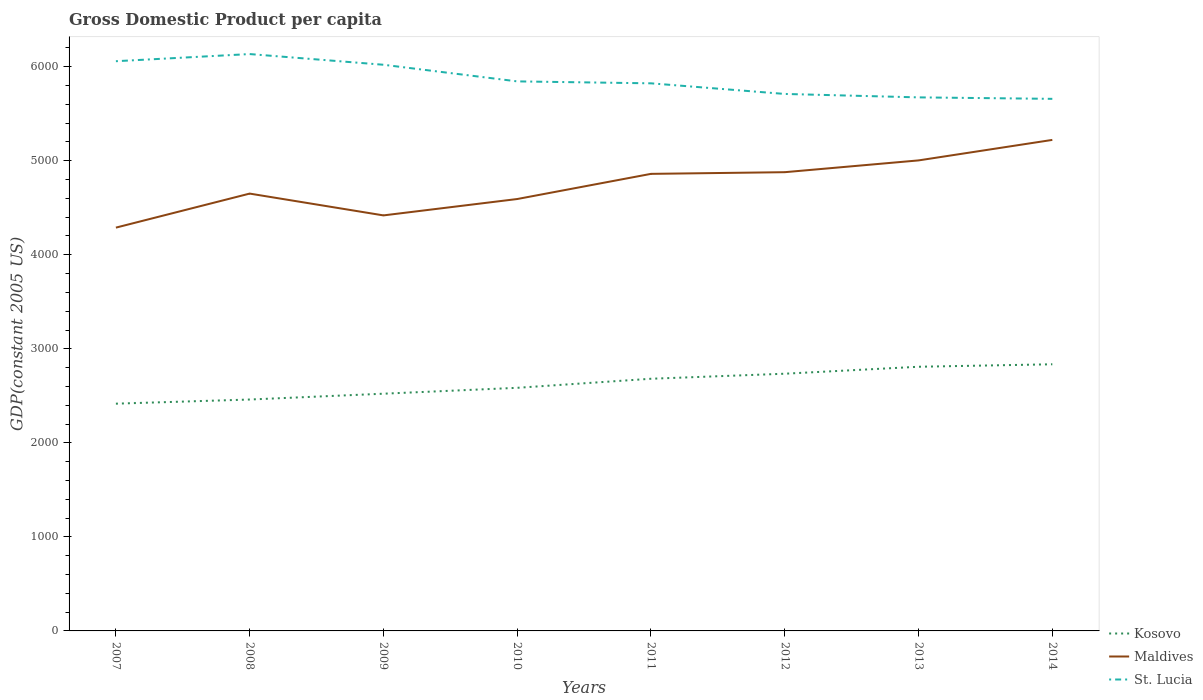How many different coloured lines are there?
Provide a succinct answer. 3. Does the line corresponding to Maldives intersect with the line corresponding to St. Lucia?
Offer a terse response. No. Across all years, what is the maximum GDP per capita in Maldives?
Ensure brevity in your answer.  4289.08. What is the total GDP per capita in St. Lucia in the graph?
Your answer should be very brief. 52.19. What is the difference between the highest and the second highest GDP per capita in Maldives?
Give a very brief answer. 932.86. Is the GDP per capita in Maldives strictly greater than the GDP per capita in St. Lucia over the years?
Offer a terse response. Yes. How many years are there in the graph?
Provide a succinct answer. 8. What is the difference between two consecutive major ticks on the Y-axis?
Offer a terse response. 1000. Are the values on the major ticks of Y-axis written in scientific E-notation?
Your answer should be compact. No. How many legend labels are there?
Provide a succinct answer. 3. What is the title of the graph?
Keep it short and to the point. Gross Domestic Product per capita. What is the label or title of the X-axis?
Make the answer very short. Years. What is the label or title of the Y-axis?
Give a very brief answer. GDP(constant 2005 US). What is the GDP(constant 2005 US) in Kosovo in 2007?
Make the answer very short. 2416.85. What is the GDP(constant 2005 US) in Maldives in 2007?
Your response must be concise. 4289.08. What is the GDP(constant 2005 US) in St. Lucia in 2007?
Offer a very short reply. 6058.86. What is the GDP(constant 2005 US) of Kosovo in 2008?
Your response must be concise. 2460.92. What is the GDP(constant 2005 US) of Maldives in 2008?
Keep it short and to the point. 4650.98. What is the GDP(constant 2005 US) in St. Lucia in 2008?
Provide a succinct answer. 6134.96. What is the GDP(constant 2005 US) of Kosovo in 2009?
Ensure brevity in your answer.  2522.81. What is the GDP(constant 2005 US) in Maldives in 2009?
Give a very brief answer. 4419.06. What is the GDP(constant 2005 US) in St. Lucia in 2009?
Make the answer very short. 6021.13. What is the GDP(constant 2005 US) in Kosovo in 2010?
Make the answer very short. 2585.46. What is the GDP(constant 2005 US) in Maldives in 2010?
Offer a very short reply. 4593.24. What is the GDP(constant 2005 US) in St. Lucia in 2010?
Your answer should be very brief. 5844.34. What is the GDP(constant 2005 US) of Kosovo in 2011?
Make the answer very short. 2681.82. What is the GDP(constant 2005 US) of Maldives in 2011?
Offer a terse response. 4860.83. What is the GDP(constant 2005 US) in St. Lucia in 2011?
Offer a terse response. 5823.61. What is the GDP(constant 2005 US) in Kosovo in 2012?
Your answer should be very brief. 2735.38. What is the GDP(constant 2005 US) in Maldives in 2012?
Offer a terse response. 4878.65. What is the GDP(constant 2005 US) in St. Lucia in 2012?
Offer a terse response. 5710.75. What is the GDP(constant 2005 US) in Kosovo in 2013?
Offer a very short reply. 2809.39. What is the GDP(constant 2005 US) in Maldives in 2013?
Your answer should be compact. 5003.96. What is the GDP(constant 2005 US) in St. Lucia in 2013?
Your response must be concise. 5674.27. What is the GDP(constant 2005 US) in Kosovo in 2014?
Your answer should be compact. 2835.78. What is the GDP(constant 2005 US) of Maldives in 2014?
Ensure brevity in your answer.  5221.95. What is the GDP(constant 2005 US) in St. Lucia in 2014?
Keep it short and to the point. 5658.56. Across all years, what is the maximum GDP(constant 2005 US) of Kosovo?
Provide a succinct answer. 2835.78. Across all years, what is the maximum GDP(constant 2005 US) of Maldives?
Your response must be concise. 5221.95. Across all years, what is the maximum GDP(constant 2005 US) of St. Lucia?
Provide a short and direct response. 6134.96. Across all years, what is the minimum GDP(constant 2005 US) of Kosovo?
Provide a short and direct response. 2416.85. Across all years, what is the minimum GDP(constant 2005 US) of Maldives?
Offer a very short reply. 4289.08. Across all years, what is the minimum GDP(constant 2005 US) in St. Lucia?
Offer a very short reply. 5658.56. What is the total GDP(constant 2005 US) in Kosovo in the graph?
Ensure brevity in your answer.  2.10e+04. What is the total GDP(constant 2005 US) in Maldives in the graph?
Make the answer very short. 3.79e+04. What is the total GDP(constant 2005 US) in St. Lucia in the graph?
Provide a succinct answer. 4.69e+04. What is the difference between the GDP(constant 2005 US) of Kosovo in 2007 and that in 2008?
Provide a succinct answer. -44.08. What is the difference between the GDP(constant 2005 US) of Maldives in 2007 and that in 2008?
Ensure brevity in your answer.  -361.89. What is the difference between the GDP(constant 2005 US) in St. Lucia in 2007 and that in 2008?
Keep it short and to the point. -76.11. What is the difference between the GDP(constant 2005 US) in Kosovo in 2007 and that in 2009?
Provide a short and direct response. -105.97. What is the difference between the GDP(constant 2005 US) of Maldives in 2007 and that in 2009?
Offer a very short reply. -129.97. What is the difference between the GDP(constant 2005 US) of St. Lucia in 2007 and that in 2009?
Your answer should be compact. 37.72. What is the difference between the GDP(constant 2005 US) of Kosovo in 2007 and that in 2010?
Offer a terse response. -168.61. What is the difference between the GDP(constant 2005 US) of Maldives in 2007 and that in 2010?
Make the answer very short. -304.15. What is the difference between the GDP(constant 2005 US) in St. Lucia in 2007 and that in 2010?
Your response must be concise. 214.51. What is the difference between the GDP(constant 2005 US) in Kosovo in 2007 and that in 2011?
Make the answer very short. -264.97. What is the difference between the GDP(constant 2005 US) of Maldives in 2007 and that in 2011?
Your response must be concise. -571.75. What is the difference between the GDP(constant 2005 US) of St. Lucia in 2007 and that in 2011?
Offer a very short reply. 235.25. What is the difference between the GDP(constant 2005 US) in Kosovo in 2007 and that in 2012?
Provide a short and direct response. -318.54. What is the difference between the GDP(constant 2005 US) of Maldives in 2007 and that in 2012?
Provide a succinct answer. -589.57. What is the difference between the GDP(constant 2005 US) in St. Lucia in 2007 and that in 2012?
Make the answer very short. 348.11. What is the difference between the GDP(constant 2005 US) in Kosovo in 2007 and that in 2013?
Provide a succinct answer. -392.55. What is the difference between the GDP(constant 2005 US) of Maldives in 2007 and that in 2013?
Provide a short and direct response. -714.88. What is the difference between the GDP(constant 2005 US) in St. Lucia in 2007 and that in 2013?
Ensure brevity in your answer.  384.58. What is the difference between the GDP(constant 2005 US) of Kosovo in 2007 and that in 2014?
Provide a succinct answer. -418.93. What is the difference between the GDP(constant 2005 US) of Maldives in 2007 and that in 2014?
Offer a very short reply. -932.87. What is the difference between the GDP(constant 2005 US) in St. Lucia in 2007 and that in 2014?
Give a very brief answer. 400.29. What is the difference between the GDP(constant 2005 US) of Kosovo in 2008 and that in 2009?
Your response must be concise. -61.89. What is the difference between the GDP(constant 2005 US) in Maldives in 2008 and that in 2009?
Offer a very short reply. 231.92. What is the difference between the GDP(constant 2005 US) of St. Lucia in 2008 and that in 2009?
Provide a succinct answer. 113.83. What is the difference between the GDP(constant 2005 US) in Kosovo in 2008 and that in 2010?
Your answer should be very brief. -124.53. What is the difference between the GDP(constant 2005 US) in Maldives in 2008 and that in 2010?
Provide a short and direct response. 57.74. What is the difference between the GDP(constant 2005 US) of St. Lucia in 2008 and that in 2010?
Offer a terse response. 290.62. What is the difference between the GDP(constant 2005 US) of Kosovo in 2008 and that in 2011?
Make the answer very short. -220.9. What is the difference between the GDP(constant 2005 US) in Maldives in 2008 and that in 2011?
Ensure brevity in your answer.  -209.85. What is the difference between the GDP(constant 2005 US) of St. Lucia in 2008 and that in 2011?
Offer a terse response. 311.35. What is the difference between the GDP(constant 2005 US) in Kosovo in 2008 and that in 2012?
Ensure brevity in your answer.  -274.46. What is the difference between the GDP(constant 2005 US) in Maldives in 2008 and that in 2012?
Provide a short and direct response. -227.68. What is the difference between the GDP(constant 2005 US) in St. Lucia in 2008 and that in 2012?
Offer a very short reply. 424.21. What is the difference between the GDP(constant 2005 US) of Kosovo in 2008 and that in 2013?
Give a very brief answer. -348.47. What is the difference between the GDP(constant 2005 US) of Maldives in 2008 and that in 2013?
Give a very brief answer. -352.99. What is the difference between the GDP(constant 2005 US) of St. Lucia in 2008 and that in 2013?
Provide a succinct answer. 460.69. What is the difference between the GDP(constant 2005 US) in Kosovo in 2008 and that in 2014?
Your response must be concise. -374.86. What is the difference between the GDP(constant 2005 US) in Maldives in 2008 and that in 2014?
Offer a terse response. -570.97. What is the difference between the GDP(constant 2005 US) of St. Lucia in 2008 and that in 2014?
Your answer should be very brief. 476.4. What is the difference between the GDP(constant 2005 US) of Kosovo in 2009 and that in 2010?
Provide a succinct answer. -62.64. What is the difference between the GDP(constant 2005 US) in Maldives in 2009 and that in 2010?
Offer a very short reply. -174.18. What is the difference between the GDP(constant 2005 US) in St. Lucia in 2009 and that in 2010?
Your answer should be compact. 176.79. What is the difference between the GDP(constant 2005 US) in Kosovo in 2009 and that in 2011?
Your response must be concise. -159.01. What is the difference between the GDP(constant 2005 US) of Maldives in 2009 and that in 2011?
Your answer should be very brief. -441.77. What is the difference between the GDP(constant 2005 US) of St. Lucia in 2009 and that in 2011?
Provide a short and direct response. 197.53. What is the difference between the GDP(constant 2005 US) in Kosovo in 2009 and that in 2012?
Your answer should be very brief. -212.57. What is the difference between the GDP(constant 2005 US) of Maldives in 2009 and that in 2012?
Provide a succinct answer. -459.6. What is the difference between the GDP(constant 2005 US) of St. Lucia in 2009 and that in 2012?
Provide a short and direct response. 310.39. What is the difference between the GDP(constant 2005 US) of Kosovo in 2009 and that in 2013?
Your response must be concise. -286.58. What is the difference between the GDP(constant 2005 US) of Maldives in 2009 and that in 2013?
Offer a very short reply. -584.91. What is the difference between the GDP(constant 2005 US) of St. Lucia in 2009 and that in 2013?
Your answer should be very brief. 346.86. What is the difference between the GDP(constant 2005 US) in Kosovo in 2009 and that in 2014?
Make the answer very short. -312.96. What is the difference between the GDP(constant 2005 US) of Maldives in 2009 and that in 2014?
Your response must be concise. -802.89. What is the difference between the GDP(constant 2005 US) in St. Lucia in 2009 and that in 2014?
Ensure brevity in your answer.  362.57. What is the difference between the GDP(constant 2005 US) in Kosovo in 2010 and that in 2011?
Provide a short and direct response. -96.36. What is the difference between the GDP(constant 2005 US) in Maldives in 2010 and that in 2011?
Provide a short and direct response. -267.59. What is the difference between the GDP(constant 2005 US) of St. Lucia in 2010 and that in 2011?
Your response must be concise. 20.73. What is the difference between the GDP(constant 2005 US) of Kosovo in 2010 and that in 2012?
Provide a short and direct response. -149.93. What is the difference between the GDP(constant 2005 US) in Maldives in 2010 and that in 2012?
Offer a very short reply. -285.42. What is the difference between the GDP(constant 2005 US) in St. Lucia in 2010 and that in 2012?
Provide a succinct answer. 133.6. What is the difference between the GDP(constant 2005 US) in Kosovo in 2010 and that in 2013?
Ensure brevity in your answer.  -223.94. What is the difference between the GDP(constant 2005 US) of Maldives in 2010 and that in 2013?
Offer a very short reply. -410.73. What is the difference between the GDP(constant 2005 US) in St. Lucia in 2010 and that in 2013?
Offer a terse response. 170.07. What is the difference between the GDP(constant 2005 US) of Kosovo in 2010 and that in 2014?
Your answer should be compact. -250.32. What is the difference between the GDP(constant 2005 US) of Maldives in 2010 and that in 2014?
Your answer should be compact. -628.71. What is the difference between the GDP(constant 2005 US) in St. Lucia in 2010 and that in 2014?
Your answer should be very brief. 185.78. What is the difference between the GDP(constant 2005 US) in Kosovo in 2011 and that in 2012?
Keep it short and to the point. -53.56. What is the difference between the GDP(constant 2005 US) in Maldives in 2011 and that in 2012?
Your answer should be compact. -17.82. What is the difference between the GDP(constant 2005 US) in St. Lucia in 2011 and that in 2012?
Provide a short and direct response. 112.86. What is the difference between the GDP(constant 2005 US) in Kosovo in 2011 and that in 2013?
Provide a succinct answer. -127.57. What is the difference between the GDP(constant 2005 US) of Maldives in 2011 and that in 2013?
Your answer should be compact. -143.13. What is the difference between the GDP(constant 2005 US) of St. Lucia in 2011 and that in 2013?
Your response must be concise. 149.33. What is the difference between the GDP(constant 2005 US) of Kosovo in 2011 and that in 2014?
Provide a short and direct response. -153.96. What is the difference between the GDP(constant 2005 US) of Maldives in 2011 and that in 2014?
Give a very brief answer. -361.12. What is the difference between the GDP(constant 2005 US) in St. Lucia in 2011 and that in 2014?
Provide a succinct answer. 165.05. What is the difference between the GDP(constant 2005 US) of Kosovo in 2012 and that in 2013?
Keep it short and to the point. -74.01. What is the difference between the GDP(constant 2005 US) in Maldives in 2012 and that in 2013?
Your response must be concise. -125.31. What is the difference between the GDP(constant 2005 US) of St. Lucia in 2012 and that in 2013?
Your answer should be very brief. 36.47. What is the difference between the GDP(constant 2005 US) in Kosovo in 2012 and that in 2014?
Offer a very short reply. -100.39. What is the difference between the GDP(constant 2005 US) in Maldives in 2012 and that in 2014?
Your answer should be compact. -343.3. What is the difference between the GDP(constant 2005 US) of St. Lucia in 2012 and that in 2014?
Make the answer very short. 52.19. What is the difference between the GDP(constant 2005 US) in Kosovo in 2013 and that in 2014?
Your answer should be very brief. -26.38. What is the difference between the GDP(constant 2005 US) in Maldives in 2013 and that in 2014?
Ensure brevity in your answer.  -217.99. What is the difference between the GDP(constant 2005 US) in St. Lucia in 2013 and that in 2014?
Keep it short and to the point. 15.71. What is the difference between the GDP(constant 2005 US) in Kosovo in 2007 and the GDP(constant 2005 US) in Maldives in 2008?
Make the answer very short. -2234.13. What is the difference between the GDP(constant 2005 US) in Kosovo in 2007 and the GDP(constant 2005 US) in St. Lucia in 2008?
Your answer should be very brief. -3718.11. What is the difference between the GDP(constant 2005 US) in Maldives in 2007 and the GDP(constant 2005 US) in St. Lucia in 2008?
Your answer should be compact. -1845.88. What is the difference between the GDP(constant 2005 US) in Kosovo in 2007 and the GDP(constant 2005 US) in Maldives in 2009?
Make the answer very short. -2002.21. What is the difference between the GDP(constant 2005 US) of Kosovo in 2007 and the GDP(constant 2005 US) of St. Lucia in 2009?
Offer a terse response. -3604.29. What is the difference between the GDP(constant 2005 US) in Maldives in 2007 and the GDP(constant 2005 US) in St. Lucia in 2009?
Ensure brevity in your answer.  -1732.05. What is the difference between the GDP(constant 2005 US) in Kosovo in 2007 and the GDP(constant 2005 US) in Maldives in 2010?
Provide a succinct answer. -2176.39. What is the difference between the GDP(constant 2005 US) of Kosovo in 2007 and the GDP(constant 2005 US) of St. Lucia in 2010?
Keep it short and to the point. -3427.49. What is the difference between the GDP(constant 2005 US) in Maldives in 2007 and the GDP(constant 2005 US) in St. Lucia in 2010?
Provide a short and direct response. -1555.26. What is the difference between the GDP(constant 2005 US) of Kosovo in 2007 and the GDP(constant 2005 US) of Maldives in 2011?
Provide a short and direct response. -2443.98. What is the difference between the GDP(constant 2005 US) in Kosovo in 2007 and the GDP(constant 2005 US) in St. Lucia in 2011?
Keep it short and to the point. -3406.76. What is the difference between the GDP(constant 2005 US) of Maldives in 2007 and the GDP(constant 2005 US) of St. Lucia in 2011?
Keep it short and to the point. -1534.53. What is the difference between the GDP(constant 2005 US) of Kosovo in 2007 and the GDP(constant 2005 US) of Maldives in 2012?
Your answer should be compact. -2461.81. What is the difference between the GDP(constant 2005 US) of Kosovo in 2007 and the GDP(constant 2005 US) of St. Lucia in 2012?
Your answer should be very brief. -3293.9. What is the difference between the GDP(constant 2005 US) of Maldives in 2007 and the GDP(constant 2005 US) of St. Lucia in 2012?
Offer a very short reply. -1421.66. What is the difference between the GDP(constant 2005 US) in Kosovo in 2007 and the GDP(constant 2005 US) in Maldives in 2013?
Your answer should be compact. -2587.11. What is the difference between the GDP(constant 2005 US) of Kosovo in 2007 and the GDP(constant 2005 US) of St. Lucia in 2013?
Keep it short and to the point. -3257.43. What is the difference between the GDP(constant 2005 US) in Maldives in 2007 and the GDP(constant 2005 US) in St. Lucia in 2013?
Make the answer very short. -1385.19. What is the difference between the GDP(constant 2005 US) of Kosovo in 2007 and the GDP(constant 2005 US) of Maldives in 2014?
Offer a terse response. -2805.1. What is the difference between the GDP(constant 2005 US) in Kosovo in 2007 and the GDP(constant 2005 US) in St. Lucia in 2014?
Your answer should be very brief. -3241.71. What is the difference between the GDP(constant 2005 US) in Maldives in 2007 and the GDP(constant 2005 US) in St. Lucia in 2014?
Provide a short and direct response. -1369.48. What is the difference between the GDP(constant 2005 US) in Kosovo in 2008 and the GDP(constant 2005 US) in Maldives in 2009?
Give a very brief answer. -1958.13. What is the difference between the GDP(constant 2005 US) in Kosovo in 2008 and the GDP(constant 2005 US) in St. Lucia in 2009?
Your answer should be very brief. -3560.21. What is the difference between the GDP(constant 2005 US) in Maldives in 2008 and the GDP(constant 2005 US) in St. Lucia in 2009?
Your answer should be compact. -1370.16. What is the difference between the GDP(constant 2005 US) of Kosovo in 2008 and the GDP(constant 2005 US) of Maldives in 2010?
Provide a short and direct response. -2132.31. What is the difference between the GDP(constant 2005 US) in Kosovo in 2008 and the GDP(constant 2005 US) in St. Lucia in 2010?
Keep it short and to the point. -3383.42. What is the difference between the GDP(constant 2005 US) of Maldives in 2008 and the GDP(constant 2005 US) of St. Lucia in 2010?
Offer a very short reply. -1193.37. What is the difference between the GDP(constant 2005 US) of Kosovo in 2008 and the GDP(constant 2005 US) of Maldives in 2011?
Offer a very short reply. -2399.91. What is the difference between the GDP(constant 2005 US) of Kosovo in 2008 and the GDP(constant 2005 US) of St. Lucia in 2011?
Ensure brevity in your answer.  -3362.69. What is the difference between the GDP(constant 2005 US) in Maldives in 2008 and the GDP(constant 2005 US) in St. Lucia in 2011?
Provide a short and direct response. -1172.63. What is the difference between the GDP(constant 2005 US) of Kosovo in 2008 and the GDP(constant 2005 US) of Maldives in 2012?
Ensure brevity in your answer.  -2417.73. What is the difference between the GDP(constant 2005 US) in Kosovo in 2008 and the GDP(constant 2005 US) in St. Lucia in 2012?
Your answer should be compact. -3249.82. What is the difference between the GDP(constant 2005 US) of Maldives in 2008 and the GDP(constant 2005 US) of St. Lucia in 2012?
Your response must be concise. -1059.77. What is the difference between the GDP(constant 2005 US) of Kosovo in 2008 and the GDP(constant 2005 US) of Maldives in 2013?
Provide a short and direct response. -2543.04. What is the difference between the GDP(constant 2005 US) of Kosovo in 2008 and the GDP(constant 2005 US) of St. Lucia in 2013?
Ensure brevity in your answer.  -3213.35. What is the difference between the GDP(constant 2005 US) of Maldives in 2008 and the GDP(constant 2005 US) of St. Lucia in 2013?
Provide a succinct answer. -1023.3. What is the difference between the GDP(constant 2005 US) in Kosovo in 2008 and the GDP(constant 2005 US) in Maldives in 2014?
Your answer should be very brief. -2761.03. What is the difference between the GDP(constant 2005 US) of Kosovo in 2008 and the GDP(constant 2005 US) of St. Lucia in 2014?
Your answer should be very brief. -3197.64. What is the difference between the GDP(constant 2005 US) in Maldives in 2008 and the GDP(constant 2005 US) in St. Lucia in 2014?
Your response must be concise. -1007.59. What is the difference between the GDP(constant 2005 US) of Kosovo in 2009 and the GDP(constant 2005 US) of Maldives in 2010?
Make the answer very short. -2070.42. What is the difference between the GDP(constant 2005 US) of Kosovo in 2009 and the GDP(constant 2005 US) of St. Lucia in 2010?
Make the answer very short. -3321.53. What is the difference between the GDP(constant 2005 US) in Maldives in 2009 and the GDP(constant 2005 US) in St. Lucia in 2010?
Ensure brevity in your answer.  -1425.29. What is the difference between the GDP(constant 2005 US) of Kosovo in 2009 and the GDP(constant 2005 US) of Maldives in 2011?
Offer a very short reply. -2338.02. What is the difference between the GDP(constant 2005 US) in Kosovo in 2009 and the GDP(constant 2005 US) in St. Lucia in 2011?
Offer a very short reply. -3300.79. What is the difference between the GDP(constant 2005 US) in Maldives in 2009 and the GDP(constant 2005 US) in St. Lucia in 2011?
Provide a short and direct response. -1404.55. What is the difference between the GDP(constant 2005 US) in Kosovo in 2009 and the GDP(constant 2005 US) in Maldives in 2012?
Make the answer very short. -2355.84. What is the difference between the GDP(constant 2005 US) in Kosovo in 2009 and the GDP(constant 2005 US) in St. Lucia in 2012?
Give a very brief answer. -3187.93. What is the difference between the GDP(constant 2005 US) of Maldives in 2009 and the GDP(constant 2005 US) of St. Lucia in 2012?
Your answer should be compact. -1291.69. What is the difference between the GDP(constant 2005 US) of Kosovo in 2009 and the GDP(constant 2005 US) of Maldives in 2013?
Make the answer very short. -2481.15. What is the difference between the GDP(constant 2005 US) of Kosovo in 2009 and the GDP(constant 2005 US) of St. Lucia in 2013?
Your response must be concise. -3151.46. What is the difference between the GDP(constant 2005 US) in Maldives in 2009 and the GDP(constant 2005 US) in St. Lucia in 2013?
Offer a terse response. -1255.22. What is the difference between the GDP(constant 2005 US) in Kosovo in 2009 and the GDP(constant 2005 US) in Maldives in 2014?
Offer a terse response. -2699.13. What is the difference between the GDP(constant 2005 US) of Kosovo in 2009 and the GDP(constant 2005 US) of St. Lucia in 2014?
Your response must be concise. -3135.75. What is the difference between the GDP(constant 2005 US) of Maldives in 2009 and the GDP(constant 2005 US) of St. Lucia in 2014?
Keep it short and to the point. -1239.51. What is the difference between the GDP(constant 2005 US) of Kosovo in 2010 and the GDP(constant 2005 US) of Maldives in 2011?
Your response must be concise. -2275.37. What is the difference between the GDP(constant 2005 US) in Kosovo in 2010 and the GDP(constant 2005 US) in St. Lucia in 2011?
Provide a short and direct response. -3238.15. What is the difference between the GDP(constant 2005 US) in Maldives in 2010 and the GDP(constant 2005 US) in St. Lucia in 2011?
Ensure brevity in your answer.  -1230.37. What is the difference between the GDP(constant 2005 US) in Kosovo in 2010 and the GDP(constant 2005 US) in Maldives in 2012?
Provide a succinct answer. -2293.2. What is the difference between the GDP(constant 2005 US) of Kosovo in 2010 and the GDP(constant 2005 US) of St. Lucia in 2012?
Offer a very short reply. -3125.29. What is the difference between the GDP(constant 2005 US) of Maldives in 2010 and the GDP(constant 2005 US) of St. Lucia in 2012?
Give a very brief answer. -1117.51. What is the difference between the GDP(constant 2005 US) in Kosovo in 2010 and the GDP(constant 2005 US) in Maldives in 2013?
Ensure brevity in your answer.  -2418.5. What is the difference between the GDP(constant 2005 US) of Kosovo in 2010 and the GDP(constant 2005 US) of St. Lucia in 2013?
Make the answer very short. -3088.82. What is the difference between the GDP(constant 2005 US) in Maldives in 2010 and the GDP(constant 2005 US) in St. Lucia in 2013?
Ensure brevity in your answer.  -1081.04. What is the difference between the GDP(constant 2005 US) of Kosovo in 2010 and the GDP(constant 2005 US) of Maldives in 2014?
Offer a terse response. -2636.49. What is the difference between the GDP(constant 2005 US) in Kosovo in 2010 and the GDP(constant 2005 US) in St. Lucia in 2014?
Make the answer very short. -3073.1. What is the difference between the GDP(constant 2005 US) of Maldives in 2010 and the GDP(constant 2005 US) of St. Lucia in 2014?
Make the answer very short. -1065.33. What is the difference between the GDP(constant 2005 US) of Kosovo in 2011 and the GDP(constant 2005 US) of Maldives in 2012?
Provide a succinct answer. -2196.83. What is the difference between the GDP(constant 2005 US) in Kosovo in 2011 and the GDP(constant 2005 US) in St. Lucia in 2012?
Make the answer very short. -3028.93. What is the difference between the GDP(constant 2005 US) of Maldives in 2011 and the GDP(constant 2005 US) of St. Lucia in 2012?
Provide a short and direct response. -849.92. What is the difference between the GDP(constant 2005 US) of Kosovo in 2011 and the GDP(constant 2005 US) of Maldives in 2013?
Provide a short and direct response. -2322.14. What is the difference between the GDP(constant 2005 US) in Kosovo in 2011 and the GDP(constant 2005 US) in St. Lucia in 2013?
Make the answer very short. -2992.45. What is the difference between the GDP(constant 2005 US) in Maldives in 2011 and the GDP(constant 2005 US) in St. Lucia in 2013?
Make the answer very short. -813.44. What is the difference between the GDP(constant 2005 US) of Kosovo in 2011 and the GDP(constant 2005 US) of Maldives in 2014?
Keep it short and to the point. -2540.13. What is the difference between the GDP(constant 2005 US) in Kosovo in 2011 and the GDP(constant 2005 US) in St. Lucia in 2014?
Your answer should be compact. -2976.74. What is the difference between the GDP(constant 2005 US) of Maldives in 2011 and the GDP(constant 2005 US) of St. Lucia in 2014?
Give a very brief answer. -797.73. What is the difference between the GDP(constant 2005 US) of Kosovo in 2012 and the GDP(constant 2005 US) of Maldives in 2013?
Keep it short and to the point. -2268.58. What is the difference between the GDP(constant 2005 US) in Kosovo in 2012 and the GDP(constant 2005 US) in St. Lucia in 2013?
Offer a very short reply. -2938.89. What is the difference between the GDP(constant 2005 US) of Maldives in 2012 and the GDP(constant 2005 US) of St. Lucia in 2013?
Offer a terse response. -795.62. What is the difference between the GDP(constant 2005 US) of Kosovo in 2012 and the GDP(constant 2005 US) of Maldives in 2014?
Your response must be concise. -2486.56. What is the difference between the GDP(constant 2005 US) in Kosovo in 2012 and the GDP(constant 2005 US) in St. Lucia in 2014?
Give a very brief answer. -2923.18. What is the difference between the GDP(constant 2005 US) in Maldives in 2012 and the GDP(constant 2005 US) in St. Lucia in 2014?
Ensure brevity in your answer.  -779.91. What is the difference between the GDP(constant 2005 US) in Kosovo in 2013 and the GDP(constant 2005 US) in Maldives in 2014?
Offer a terse response. -2412.56. What is the difference between the GDP(constant 2005 US) of Kosovo in 2013 and the GDP(constant 2005 US) of St. Lucia in 2014?
Provide a short and direct response. -2849.17. What is the difference between the GDP(constant 2005 US) in Maldives in 2013 and the GDP(constant 2005 US) in St. Lucia in 2014?
Your response must be concise. -654.6. What is the average GDP(constant 2005 US) in Kosovo per year?
Offer a very short reply. 2631.05. What is the average GDP(constant 2005 US) in Maldives per year?
Provide a short and direct response. 4739.72. What is the average GDP(constant 2005 US) in St. Lucia per year?
Make the answer very short. 5865.81. In the year 2007, what is the difference between the GDP(constant 2005 US) in Kosovo and GDP(constant 2005 US) in Maldives?
Offer a terse response. -1872.24. In the year 2007, what is the difference between the GDP(constant 2005 US) of Kosovo and GDP(constant 2005 US) of St. Lucia?
Offer a terse response. -3642.01. In the year 2007, what is the difference between the GDP(constant 2005 US) of Maldives and GDP(constant 2005 US) of St. Lucia?
Keep it short and to the point. -1769.77. In the year 2008, what is the difference between the GDP(constant 2005 US) of Kosovo and GDP(constant 2005 US) of Maldives?
Ensure brevity in your answer.  -2190.05. In the year 2008, what is the difference between the GDP(constant 2005 US) of Kosovo and GDP(constant 2005 US) of St. Lucia?
Your response must be concise. -3674.04. In the year 2008, what is the difference between the GDP(constant 2005 US) in Maldives and GDP(constant 2005 US) in St. Lucia?
Ensure brevity in your answer.  -1483.98. In the year 2009, what is the difference between the GDP(constant 2005 US) in Kosovo and GDP(constant 2005 US) in Maldives?
Make the answer very short. -1896.24. In the year 2009, what is the difference between the GDP(constant 2005 US) of Kosovo and GDP(constant 2005 US) of St. Lucia?
Provide a succinct answer. -3498.32. In the year 2009, what is the difference between the GDP(constant 2005 US) in Maldives and GDP(constant 2005 US) in St. Lucia?
Give a very brief answer. -1602.08. In the year 2010, what is the difference between the GDP(constant 2005 US) in Kosovo and GDP(constant 2005 US) in Maldives?
Provide a succinct answer. -2007.78. In the year 2010, what is the difference between the GDP(constant 2005 US) in Kosovo and GDP(constant 2005 US) in St. Lucia?
Give a very brief answer. -3258.88. In the year 2010, what is the difference between the GDP(constant 2005 US) in Maldives and GDP(constant 2005 US) in St. Lucia?
Offer a very short reply. -1251.11. In the year 2011, what is the difference between the GDP(constant 2005 US) of Kosovo and GDP(constant 2005 US) of Maldives?
Offer a terse response. -2179.01. In the year 2011, what is the difference between the GDP(constant 2005 US) of Kosovo and GDP(constant 2005 US) of St. Lucia?
Provide a succinct answer. -3141.79. In the year 2011, what is the difference between the GDP(constant 2005 US) in Maldives and GDP(constant 2005 US) in St. Lucia?
Give a very brief answer. -962.78. In the year 2012, what is the difference between the GDP(constant 2005 US) of Kosovo and GDP(constant 2005 US) of Maldives?
Your answer should be very brief. -2143.27. In the year 2012, what is the difference between the GDP(constant 2005 US) of Kosovo and GDP(constant 2005 US) of St. Lucia?
Make the answer very short. -2975.36. In the year 2012, what is the difference between the GDP(constant 2005 US) in Maldives and GDP(constant 2005 US) in St. Lucia?
Keep it short and to the point. -832.09. In the year 2013, what is the difference between the GDP(constant 2005 US) of Kosovo and GDP(constant 2005 US) of Maldives?
Make the answer very short. -2194.57. In the year 2013, what is the difference between the GDP(constant 2005 US) of Kosovo and GDP(constant 2005 US) of St. Lucia?
Offer a very short reply. -2864.88. In the year 2013, what is the difference between the GDP(constant 2005 US) in Maldives and GDP(constant 2005 US) in St. Lucia?
Your response must be concise. -670.31. In the year 2014, what is the difference between the GDP(constant 2005 US) of Kosovo and GDP(constant 2005 US) of Maldives?
Your answer should be compact. -2386.17. In the year 2014, what is the difference between the GDP(constant 2005 US) of Kosovo and GDP(constant 2005 US) of St. Lucia?
Offer a terse response. -2822.78. In the year 2014, what is the difference between the GDP(constant 2005 US) in Maldives and GDP(constant 2005 US) in St. Lucia?
Your answer should be very brief. -436.61. What is the ratio of the GDP(constant 2005 US) in Kosovo in 2007 to that in 2008?
Offer a terse response. 0.98. What is the ratio of the GDP(constant 2005 US) in Maldives in 2007 to that in 2008?
Give a very brief answer. 0.92. What is the ratio of the GDP(constant 2005 US) in St. Lucia in 2007 to that in 2008?
Your answer should be very brief. 0.99. What is the ratio of the GDP(constant 2005 US) in Kosovo in 2007 to that in 2009?
Your answer should be very brief. 0.96. What is the ratio of the GDP(constant 2005 US) of Maldives in 2007 to that in 2009?
Your response must be concise. 0.97. What is the ratio of the GDP(constant 2005 US) in St. Lucia in 2007 to that in 2009?
Provide a short and direct response. 1.01. What is the ratio of the GDP(constant 2005 US) in Kosovo in 2007 to that in 2010?
Provide a short and direct response. 0.93. What is the ratio of the GDP(constant 2005 US) in Maldives in 2007 to that in 2010?
Your answer should be very brief. 0.93. What is the ratio of the GDP(constant 2005 US) in St. Lucia in 2007 to that in 2010?
Your answer should be compact. 1.04. What is the ratio of the GDP(constant 2005 US) of Kosovo in 2007 to that in 2011?
Your answer should be compact. 0.9. What is the ratio of the GDP(constant 2005 US) of Maldives in 2007 to that in 2011?
Offer a terse response. 0.88. What is the ratio of the GDP(constant 2005 US) of St. Lucia in 2007 to that in 2011?
Keep it short and to the point. 1.04. What is the ratio of the GDP(constant 2005 US) of Kosovo in 2007 to that in 2012?
Provide a short and direct response. 0.88. What is the ratio of the GDP(constant 2005 US) of Maldives in 2007 to that in 2012?
Keep it short and to the point. 0.88. What is the ratio of the GDP(constant 2005 US) of St. Lucia in 2007 to that in 2012?
Ensure brevity in your answer.  1.06. What is the ratio of the GDP(constant 2005 US) in Kosovo in 2007 to that in 2013?
Your response must be concise. 0.86. What is the ratio of the GDP(constant 2005 US) in St. Lucia in 2007 to that in 2013?
Keep it short and to the point. 1.07. What is the ratio of the GDP(constant 2005 US) of Kosovo in 2007 to that in 2014?
Keep it short and to the point. 0.85. What is the ratio of the GDP(constant 2005 US) of Maldives in 2007 to that in 2014?
Offer a very short reply. 0.82. What is the ratio of the GDP(constant 2005 US) of St. Lucia in 2007 to that in 2014?
Ensure brevity in your answer.  1.07. What is the ratio of the GDP(constant 2005 US) of Kosovo in 2008 to that in 2009?
Your answer should be compact. 0.98. What is the ratio of the GDP(constant 2005 US) of Maldives in 2008 to that in 2009?
Keep it short and to the point. 1.05. What is the ratio of the GDP(constant 2005 US) of St. Lucia in 2008 to that in 2009?
Offer a terse response. 1.02. What is the ratio of the GDP(constant 2005 US) in Kosovo in 2008 to that in 2010?
Provide a succinct answer. 0.95. What is the ratio of the GDP(constant 2005 US) in Maldives in 2008 to that in 2010?
Ensure brevity in your answer.  1.01. What is the ratio of the GDP(constant 2005 US) of St. Lucia in 2008 to that in 2010?
Your answer should be compact. 1.05. What is the ratio of the GDP(constant 2005 US) in Kosovo in 2008 to that in 2011?
Your answer should be very brief. 0.92. What is the ratio of the GDP(constant 2005 US) in Maldives in 2008 to that in 2011?
Offer a terse response. 0.96. What is the ratio of the GDP(constant 2005 US) of St. Lucia in 2008 to that in 2011?
Offer a very short reply. 1.05. What is the ratio of the GDP(constant 2005 US) in Kosovo in 2008 to that in 2012?
Offer a very short reply. 0.9. What is the ratio of the GDP(constant 2005 US) in Maldives in 2008 to that in 2012?
Your answer should be very brief. 0.95. What is the ratio of the GDP(constant 2005 US) in St. Lucia in 2008 to that in 2012?
Your answer should be compact. 1.07. What is the ratio of the GDP(constant 2005 US) of Kosovo in 2008 to that in 2013?
Make the answer very short. 0.88. What is the ratio of the GDP(constant 2005 US) of Maldives in 2008 to that in 2013?
Keep it short and to the point. 0.93. What is the ratio of the GDP(constant 2005 US) in St. Lucia in 2008 to that in 2013?
Provide a succinct answer. 1.08. What is the ratio of the GDP(constant 2005 US) of Kosovo in 2008 to that in 2014?
Make the answer very short. 0.87. What is the ratio of the GDP(constant 2005 US) of Maldives in 2008 to that in 2014?
Keep it short and to the point. 0.89. What is the ratio of the GDP(constant 2005 US) in St. Lucia in 2008 to that in 2014?
Provide a succinct answer. 1.08. What is the ratio of the GDP(constant 2005 US) in Kosovo in 2009 to that in 2010?
Provide a succinct answer. 0.98. What is the ratio of the GDP(constant 2005 US) of Maldives in 2009 to that in 2010?
Your response must be concise. 0.96. What is the ratio of the GDP(constant 2005 US) of St. Lucia in 2009 to that in 2010?
Offer a terse response. 1.03. What is the ratio of the GDP(constant 2005 US) of Kosovo in 2009 to that in 2011?
Make the answer very short. 0.94. What is the ratio of the GDP(constant 2005 US) in St. Lucia in 2009 to that in 2011?
Provide a succinct answer. 1.03. What is the ratio of the GDP(constant 2005 US) in Kosovo in 2009 to that in 2012?
Give a very brief answer. 0.92. What is the ratio of the GDP(constant 2005 US) of Maldives in 2009 to that in 2012?
Your answer should be compact. 0.91. What is the ratio of the GDP(constant 2005 US) of St. Lucia in 2009 to that in 2012?
Your answer should be compact. 1.05. What is the ratio of the GDP(constant 2005 US) of Kosovo in 2009 to that in 2013?
Keep it short and to the point. 0.9. What is the ratio of the GDP(constant 2005 US) of Maldives in 2009 to that in 2013?
Your answer should be very brief. 0.88. What is the ratio of the GDP(constant 2005 US) in St. Lucia in 2009 to that in 2013?
Offer a terse response. 1.06. What is the ratio of the GDP(constant 2005 US) of Kosovo in 2009 to that in 2014?
Offer a very short reply. 0.89. What is the ratio of the GDP(constant 2005 US) of Maldives in 2009 to that in 2014?
Your answer should be very brief. 0.85. What is the ratio of the GDP(constant 2005 US) in St. Lucia in 2009 to that in 2014?
Make the answer very short. 1.06. What is the ratio of the GDP(constant 2005 US) in Kosovo in 2010 to that in 2011?
Ensure brevity in your answer.  0.96. What is the ratio of the GDP(constant 2005 US) of Maldives in 2010 to that in 2011?
Your answer should be very brief. 0.94. What is the ratio of the GDP(constant 2005 US) of Kosovo in 2010 to that in 2012?
Make the answer very short. 0.95. What is the ratio of the GDP(constant 2005 US) in Maldives in 2010 to that in 2012?
Make the answer very short. 0.94. What is the ratio of the GDP(constant 2005 US) in St. Lucia in 2010 to that in 2012?
Keep it short and to the point. 1.02. What is the ratio of the GDP(constant 2005 US) of Kosovo in 2010 to that in 2013?
Provide a short and direct response. 0.92. What is the ratio of the GDP(constant 2005 US) in Maldives in 2010 to that in 2013?
Your answer should be compact. 0.92. What is the ratio of the GDP(constant 2005 US) of Kosovo in 2010 to that in 2014?
Offer a very short reply. 0.91. What is the ratio of the GDP(constant 2005 US) of Maldives in 2010 to that in 2014?
Give a very brief answer. 0.88. What is the ratio of the GDP(constant 2005 US) of St. Lucia in 2010 to that in 2014?
Provide a succinct answer. 1.03. What is the ratio of the GDP(constant 2005 US) in Kosovo in 2011 to that in 2012?
Offer a terse response. 0.98. What is the ratio of the GDP(constant 2005 US) of Maldives in 2011 to that in 2012?
Provide a short and direct response. 1. What is the ratio of the GDP(constant 2005 US) of St. Lucia in 2011 to that in 2012?
Give a very brief answer. 1.02. What is the ratio of the GDP(constant 2005 US) of Kosovo in 2011 to that in 2013?
Ensure brevity in your answer.  0.95. What is the ratio of the GDP(constant 2005 US) of Maldives in 2011 to that in 2013?
Offer a terse response. 0.97. What is the ratio of the GDP(constant 2005 US) of St. Lucia in 2011 to that in 2013?
Provide a short and direct response. 1.03. What is the ratio of the GDP(constant 2005 US) of Kosovo in 2011 to that in 2014?
Provide a succinct answer. 0.95. What is the ratio of the GDP(constant 2005 US) of Maldives in 2011 to that in 2014?
Your response must be concise. 0.93. What is the ratio of the GDP(constant 2005 US) of St. Lucia in 2011 to that in 2014?
Your answer should be compact. 1.03. What is the ratio of the GDP(constant 2005 US) of Kosovo in 2012 to that in 2013?
Provide a short and direct response. 0.97. What is the ratio of the GDP(constant 2005 US) of Maldives in 2012 to that in 2013?
Provide a short and direct response. 0.97. What is the ratio of the GDP(constant 2005 US) in St. Lucia in 2012 to that in 2013?
Your answer should be very brief. 1.01. What is the ratio of the GDP(constant 2005 US) of Kosovo in 2012 to that in 2014?
Give a very brief answer. 0.96. What is the ratio of the GDP(constant 2005 US) of Maldives in 2012 to that in 2014?
Your answer should be very brief. 0.93. What is the ratio of the GDP(constant 2005 US) in St. Lucia in 2012 to that in 2014?
Keep it short and to the point. 1.01. What is the difference between the highest and the second highest GDP(constant 2005 US) in Kosovo?
Provide a succinct answer. 26.38. What is the difference between the highest and the second highest GDP(constant 2005 US) in Maldives?
Provide a succinct answer. 217.99. What is the difference between the highest and the second highest GDP(constant 2005 US) in St. Lucia?
Provide a succinct answer. 76.11. What is the difference between the highest and the lowest GDP(constant 2005 US) of Kosovo?
Provide a short and direct response. 418.93. What is the difference between the highest and the lowest GDP(constant 2005 US) of Maldives?
Provide a succinct answer. 932.87. What is the difference between the highest and the lowest GDP(constant 2005 US) in St. Lucia?
Make the answer very short. 476.4. 